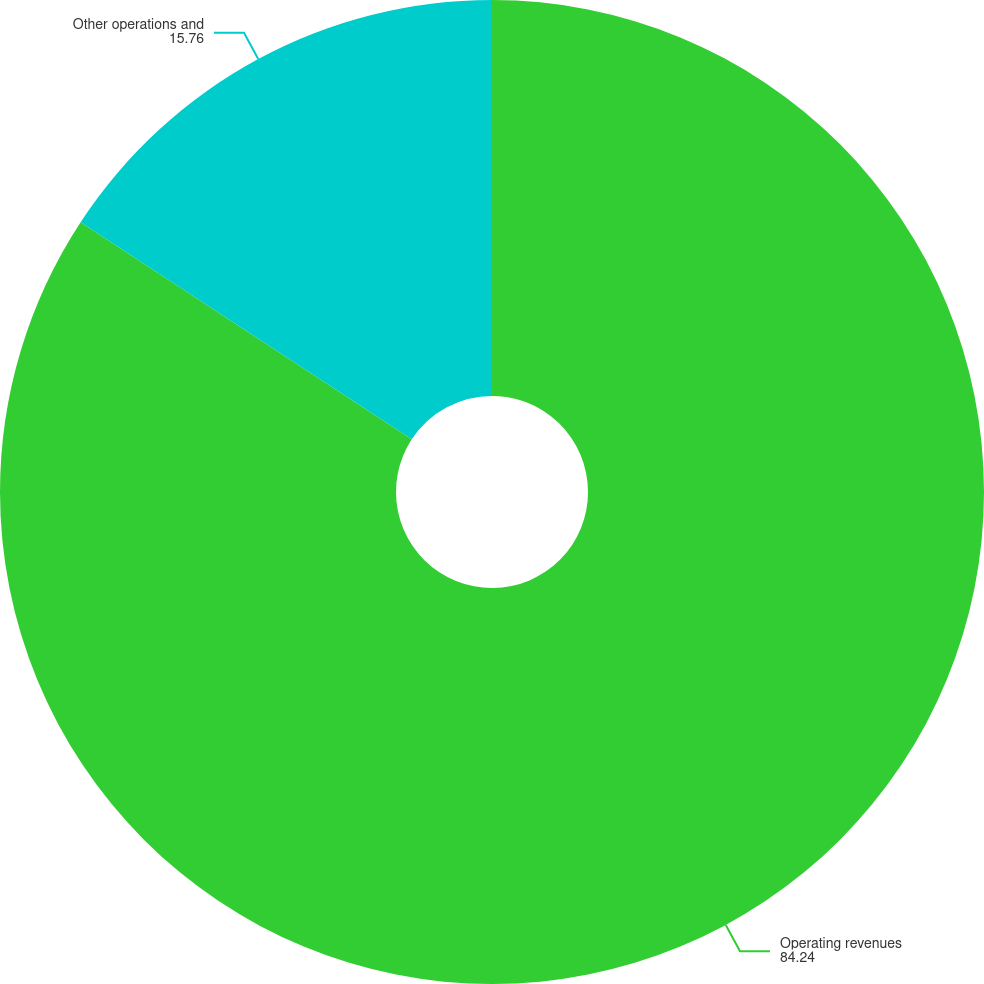<chart> <loc_0><loc_0><loc_500><loc_500><pie_chart><fcel>Operating revenues<fcel>Other operations and<nl><fcel>84.24%<fcel>15.76%<nl></chart> 